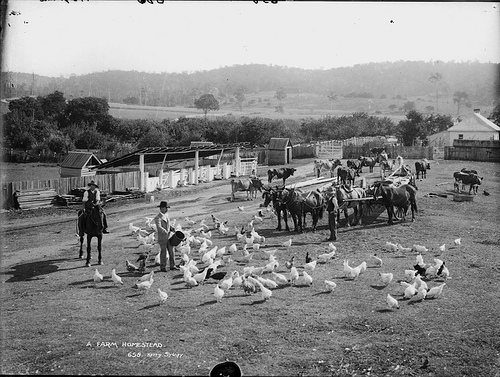What activities do the people in the image seem to be engaged in? The individuals in the image are likely involved in farm work. One appears to be supervising or tending to the birds, another is seated on a horse, possibly overseeing the farm activities, and others are on horse-drawn carts which might be used for transporting goods or agricultural produce. 